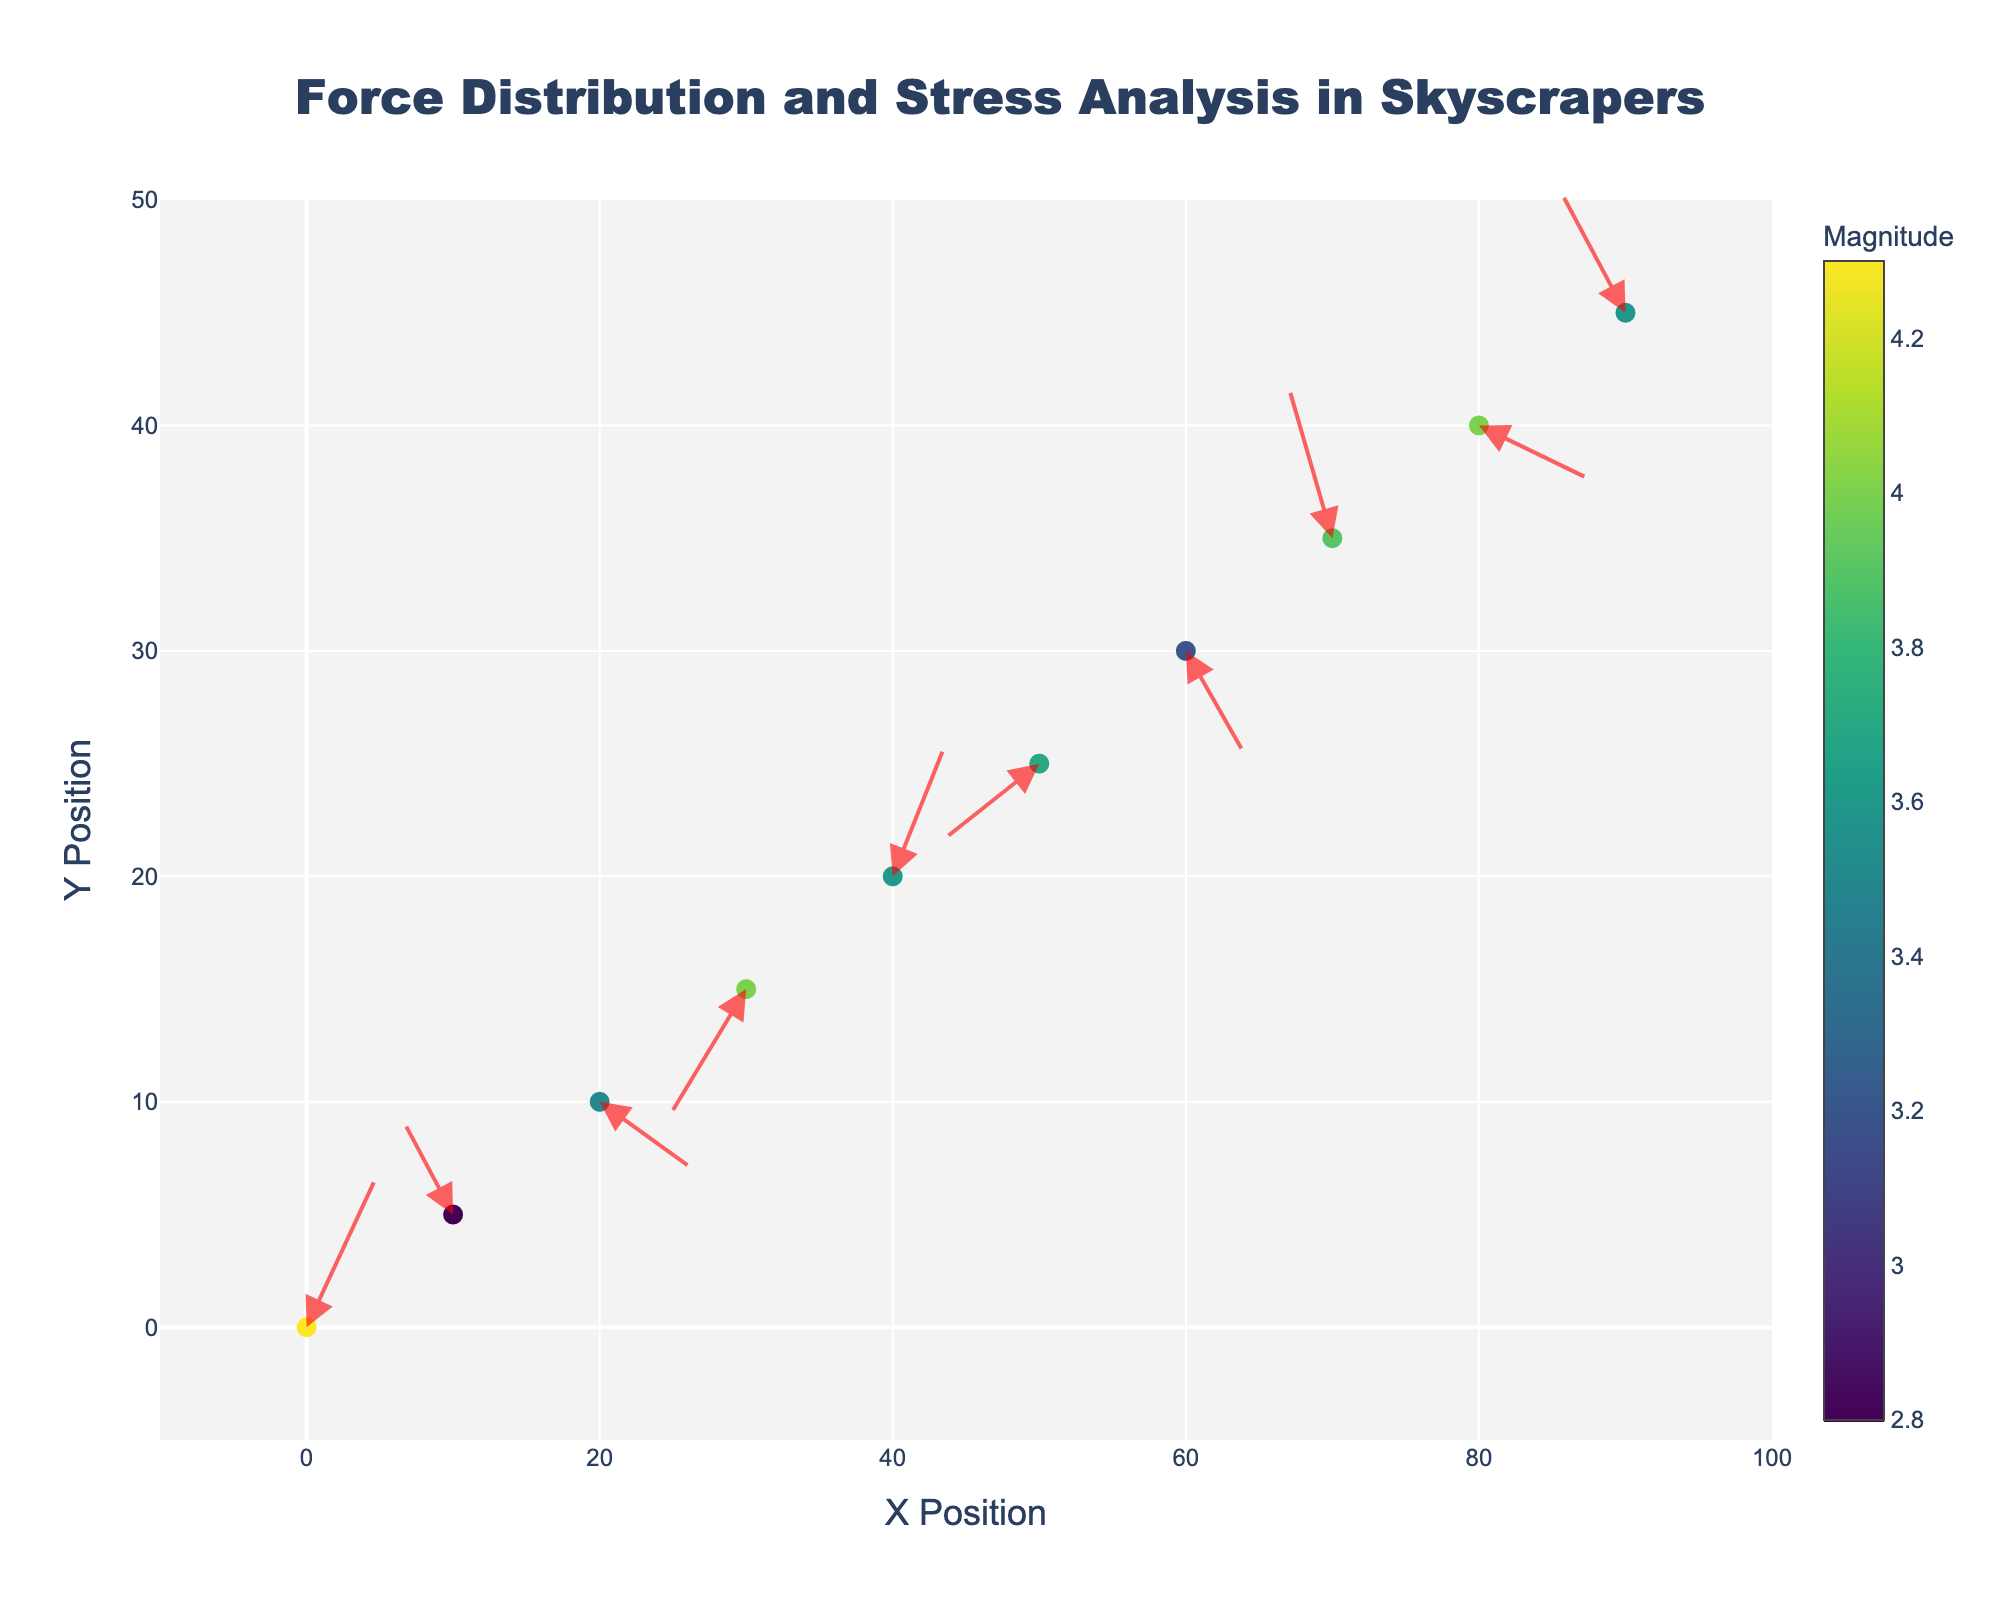What is the title of the figure? The title is usually at the top of the figure, written in larger font size to attract immediate attention.
Answer: Force Distribution and Stress Analysis in Skyscrapers How many data points are represented in the plot? The number of data points can be counted by looking at the number of markers or arrows in the plot.
Answer: 10 What are the axis labels? Axis labels are typically located along the axes. In this plot, they should specify the physical dimensions represented.
Answer: X Position (horizontal axis) and Y Position (vertical axis) Which component has the highest magnitude force? By observing the color scale, which is used to show magnitude, the component corresponding to the color closest to the top of the colorbar has the highest magnitude.
Answer: Vertical load How is the "Wind shear" force oriented? The orientation can be identified by looking at the direction of the arrow originating from the point labeled "Wind shear." In this case, the arrow should point from the visual representation of the data point at x=10, y=5.
Answer: (-1.8, 2.2) What is the average magnitude of the forces represented in the plot? Add all the magnitudes and then divide by the number of data points to get the average. (4.3+2.8+3.5+4.0+3.6+3.7+3.2+3.9+4.0+3.6)/10 = 3.66
Answer: 3.66 Which component experiences the most negative horizontal force? Examine the 'u' (horizontal component) value for each component and identify the most negative value. The corresponding component is the answer.
Answer: Dead load Which two components have forces in opposite directions along the x-axis? Compare horizontal vectors ('u') for each component. Opposite direction implies one positive and one negative. For example, Vertical load (u=2.5) and Thermal stress (u=-2.7).
Answer: Vertical load and Thermal stress What is the range of the x-axis and y-axis? By looking at the axis range provided at the plot's edges, one can see the minimum and maximum values each axis covers.
Answer: x-axis: -10 to 100, y-axis: -5 to 50 Which force component is located at the highest y position? Identify the y coordinate with the highest value by observing the data points and seeing which label corresponds.
Answer: Impact load 